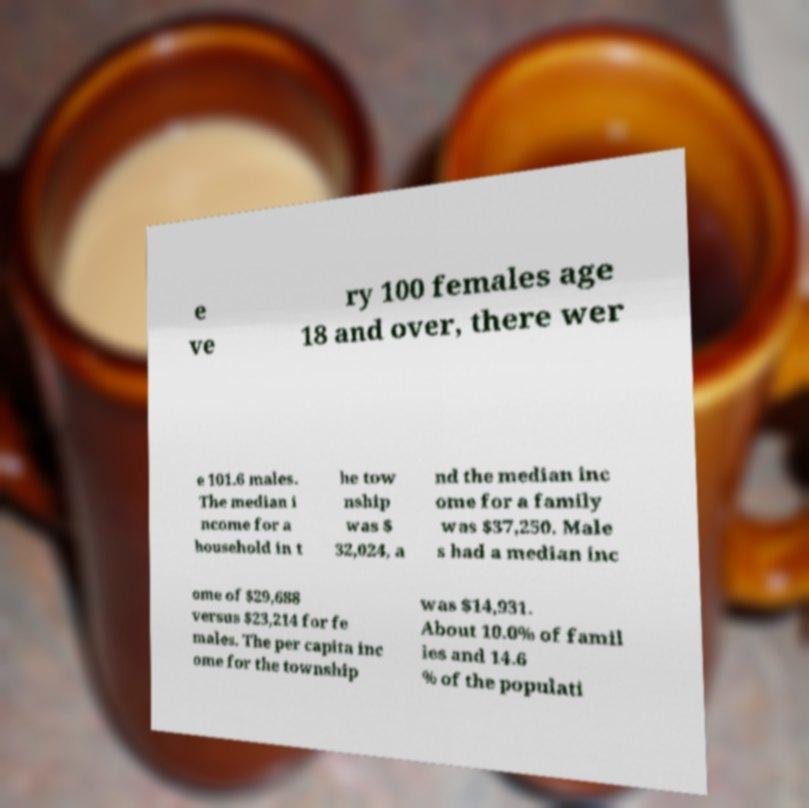Could you extract and type out the text from this image? e ve ry 100 females age 18 and over, there wer e 101.6 males. The median i ncome for a household in t he tow nship was $ 32,024, a nd the median inc ome for a family was $37,250. Male s had a median inc ome of $29,688 versus $23,214 for fe males. The per capita inc ome for the township was $14,931. About 10.0% of famil ies and 14.6 % of the populati 